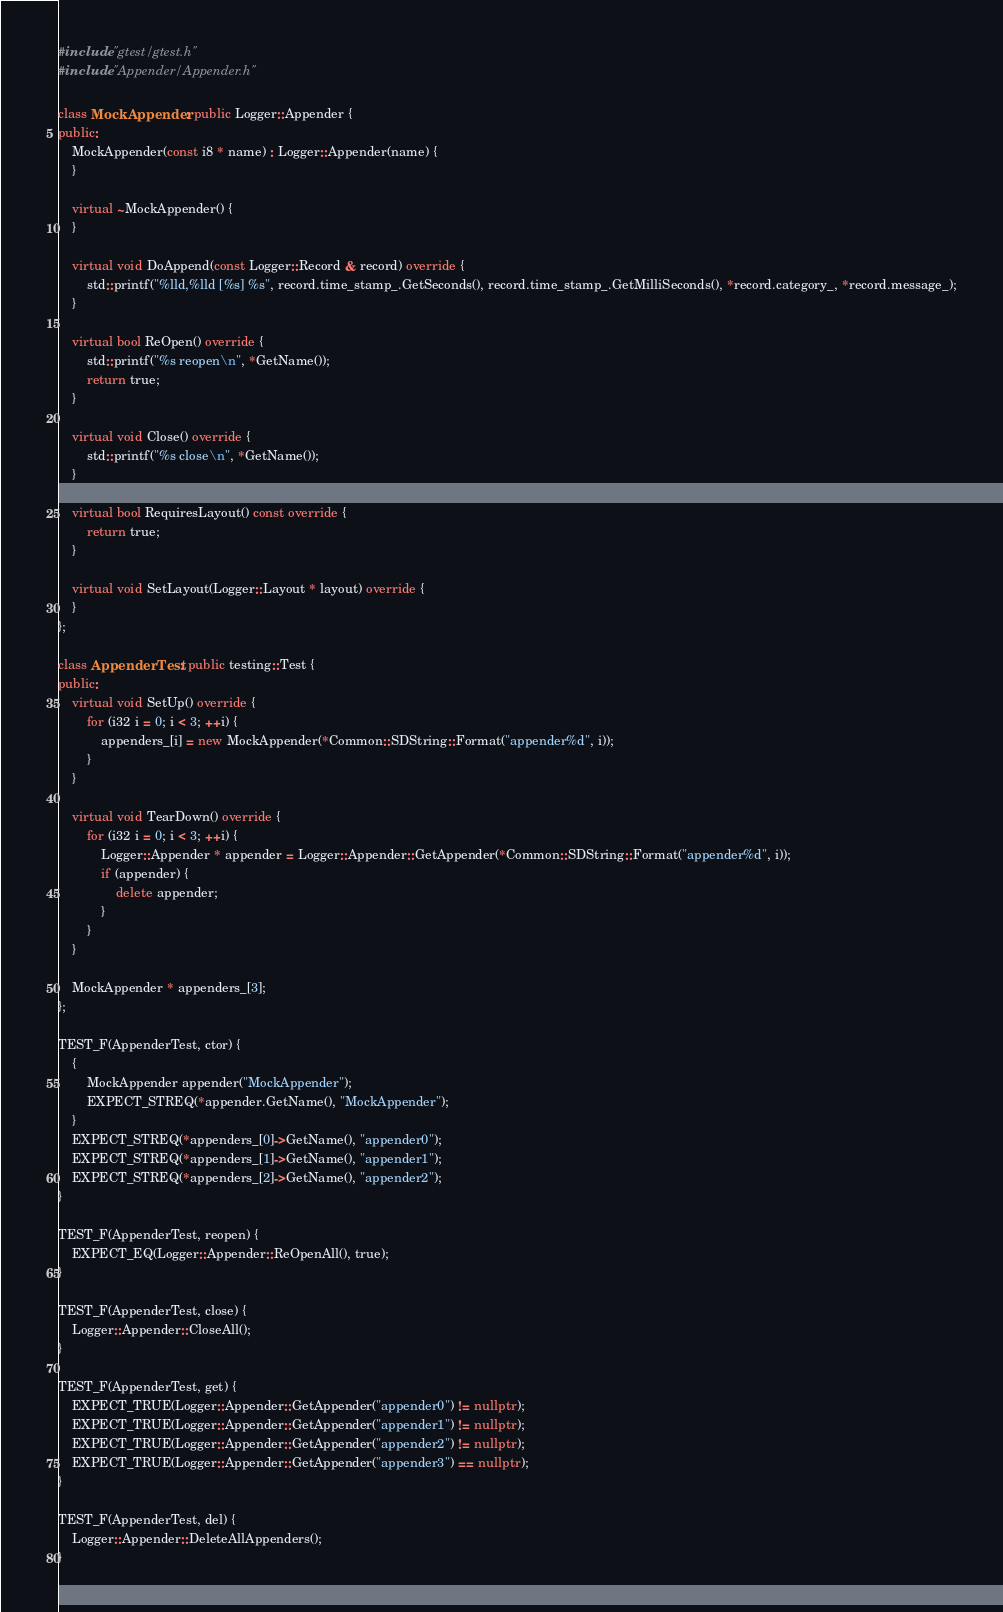<code> <loc_0><loc_0><loc_500><loc_500><_C++_>#include "gtest/gtest.h"
#include "Appender/Appender.h"

class MockAppender : public Logger::Appender {
public:
	MockAppender(const i8 * name) : Logger::Appender(name) {
	}

	virtual ~MockAppender() {
	}

	virtual void DoAppend(const Logger::Record & record) override {
		std::printf("%lld,%lld [%s] %s", record.time_stamp_.GetSeconds(), record.time_stamp_.GetMilliSeconds(), *record.category_, *record.message_);
	}

	virtual bool ReOpen() override {
		std::printf("%s reopen\n", *GetName());
		return true;
	}

	virtual void Close() override {
		std::printf("%s close\n", *GetName());
	}

	virtual bool RequiresLayout() const override {
		return true;
	}

	virtual void SetLayout(Logger::Layout * layout) override {
	}
};

class AppenderTest : public testing::Test {
public:
	virtual void SetUp() override {
		for (i32 i = 0; i < 3; ++i) {
			appenders_[i] = new MockAppender(*Common::SDString::Format("appender%d", i));
		}
	}

	virtual void TearDown() override {
		for (i32 i = 0; i < 3; ++i) {
			Logger::Appender * appender = Logger::Appender::GetAppender(*Common::SDString::Format("appender%d", i));
			if (appender) {
				delete appender;
			}
		}
	}

	MockAppender * appenders_[3];
};

TEST_F(AppenderTest, ctor) {
	{
		MockAppender appender("MockAppender");
		EXPECT_STREQ(*appender.GetName(), "MockAppender");
	}
	EXPECT_STREQ(*appenders_[0]->GetName(), "appender0");
	EXPECT_STREQ(*appenders_[1]->GetName(), "appender1");
	EXPECT_STREQ(*appenders_[2]->GetName(), "appender2");
}

TEST_F(AppenderTest, reopen) {
	EXPECT_EQ(Logger::Appender::ReOpenAll(), true);
}

TEST_F(AppenderTest, close) {
	Logger::Appender::CloseAll();
}

TEST_F(AppenderTest, get) {
	EXPECT_TRUE(Logger::Appender::GetAppender("appender0") != nullptr);
	EXPECT_TRUE(Logger::Appender::GetAppender("appender1") != nullptr);
	EXPECT_TRUE(Logger::Appender::GetAppender("appender2") != nullptr);
	EXPECT_TRUE(Logger::Appender::GetAppender("appender3") == nullptr);
}

TEST_F(AppenderTest, del) {
	Logger::Appender::DeleteAllAppenders();
}</code> 